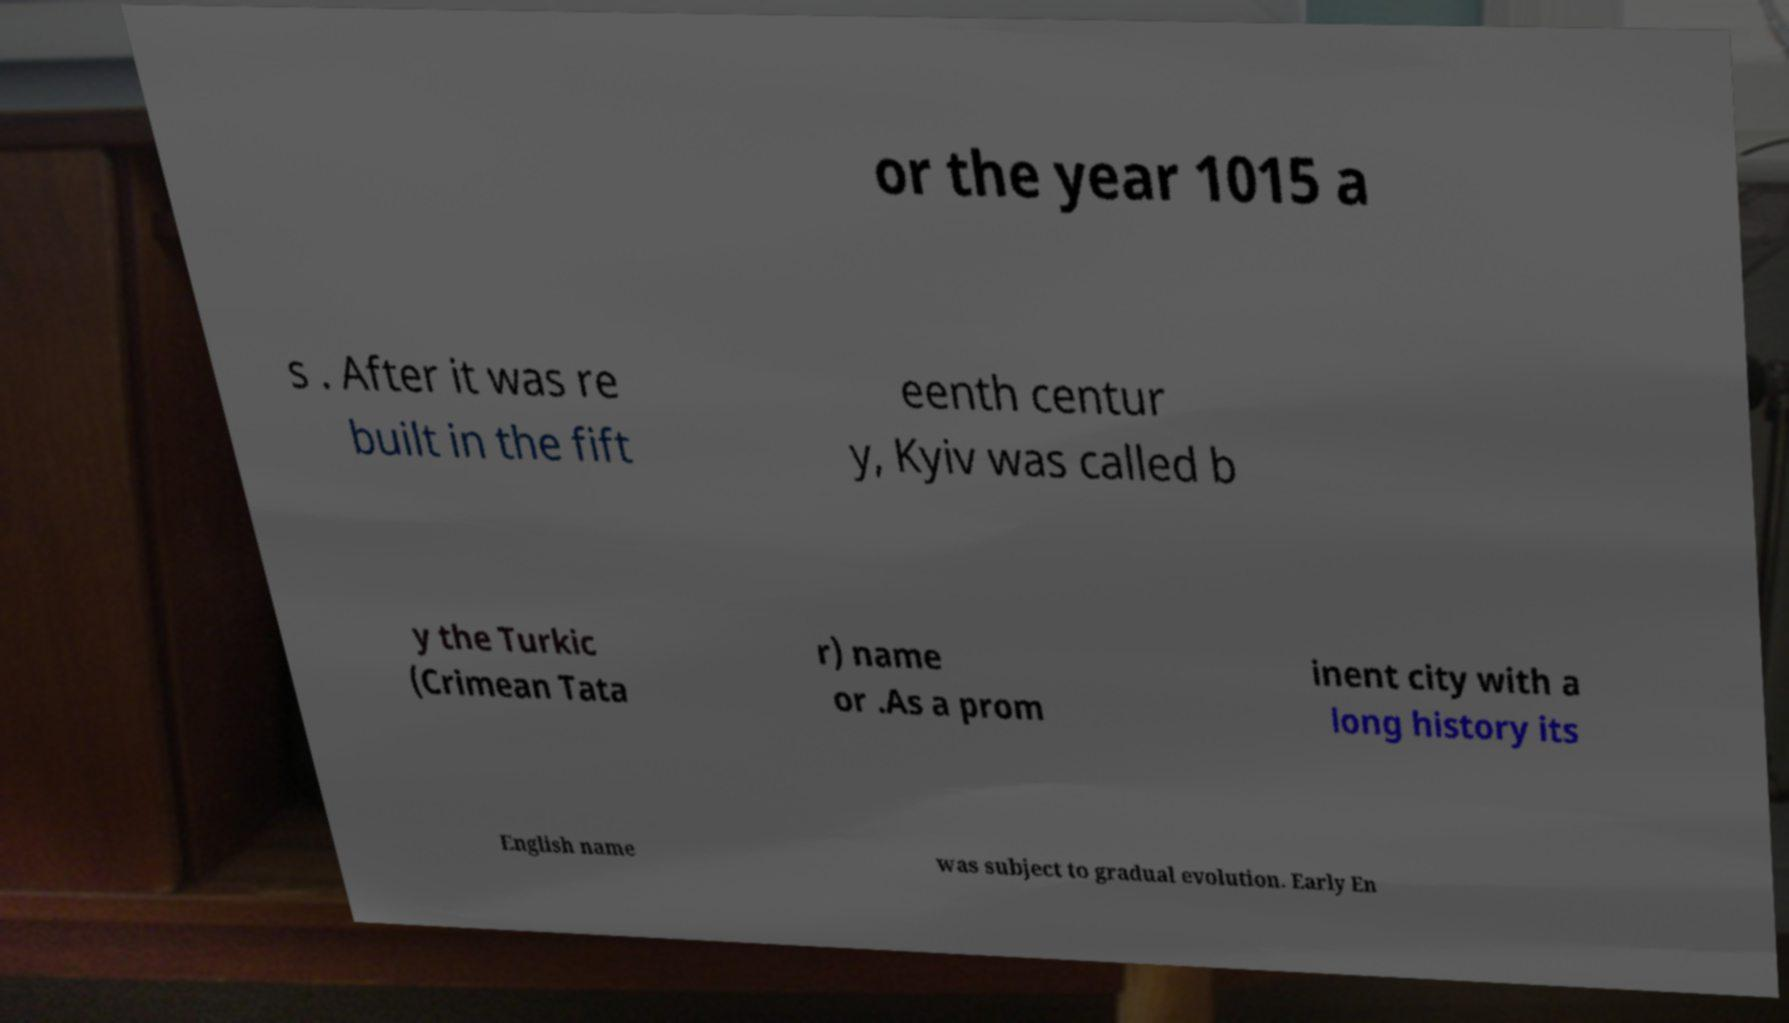There's text embedded in this image that I need extracted. Can you transcribe it verbatim? or the year 1015 a s . After it was re built in the fift eenth centur y, Kyiv was called b y the Turkic (Crimean Tata r) name or .As a prom inent city with a long history its English name was subject to gradual evolution. Early En 